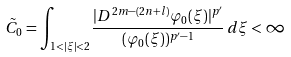<formula> <loc_0><loc_0><loc_500><loc_500>\tilde { C } _ { 0 } = \int _ { 1 < | \xi | < 2 } \frac { | D ^ { 2 m - ( 2 n + l ) } \varphi _ { 0 } ( \xi ) | ^ { p ^ { \prime } } } { ( \varphi _ { 0 } ( \xi ) ) ^ { p ^ { \prime } - 1 } } \, d \xi < \infty</formula> 